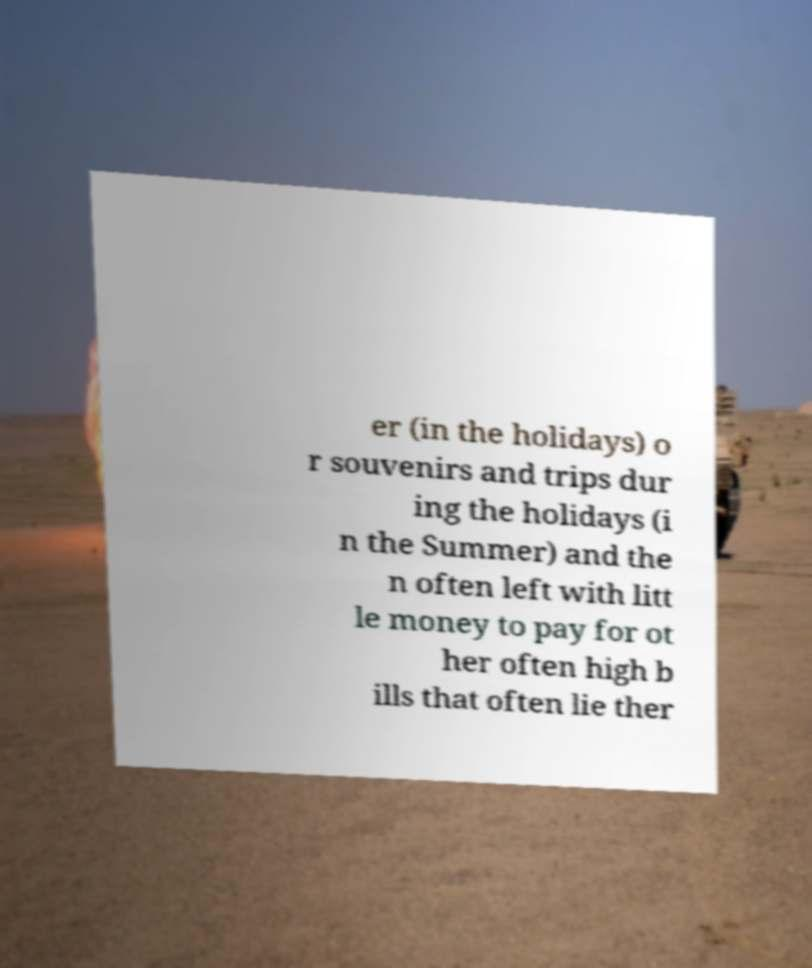Please identify and transcribe the text found in this image. er (in the holidays) o r souvenirs and trips dur ing the holidays (i n the Summer) and the n often left with litt le money to pay for ot her often high b ills that often lie ther 